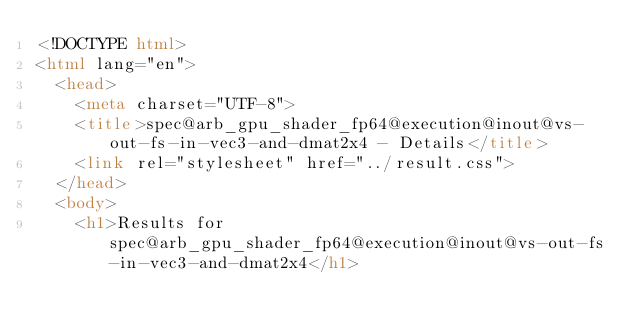<code> <loc_0><loc_0><loc_500><loc_500><_HTML_><!DOCTYPE html>
<html lang="en">
  <head>
    <meta charset="UTF-8">
    <title>spec@arb_gpu_shader_fp64@execution@inout@vs-out-fs-in-vec3-and-dmat2x4 - Details</title>
    <link rel="stylesheet" href="../result.css">
  </head>
  <body>
    <h1>Results for spec@arb_gpu_shader_fp64@execution@inout@vs-out-fs-in-vec3-and-dmat2x4</h1></code> 